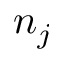<formula> <loc_0><loc_0><loc_500><loc_500>n _ { j }</formula> 